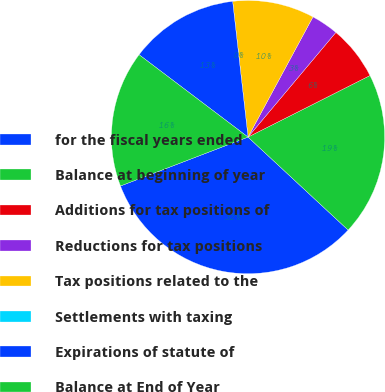<chart> <loc_0><loc_0><loc_500><loc_500><pie_chart><fcel>for the fiscal years ended<fcel>Balance at beginning of year<fcel>Additions for tax positions of<fcel>Reductions for tax positions<fcel>Tax positions related to the<fcel>Settlements with taxing<fcel>Expirations of statute of<fcel>Balance at End of Year<nl><fcel>32.26%<fcel>19.35%<fcel>6.45%<fcel>3.23%<fcel>9.68%<fcel>0.0%<fcel>12.9%<fcel>16.13%<nl></chart> 